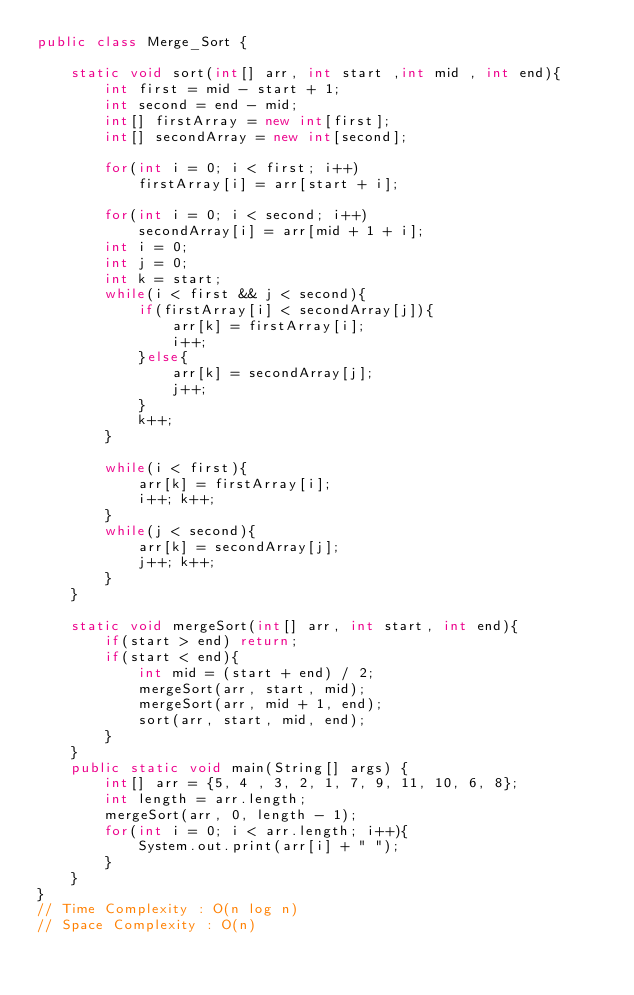<code> <loc_0><loc_0><loc_500><loc_500><_Java_>public class Merge_Sort {

    static void sort(int[] arr, int start ,int mid , int end){
        int first = mid - start + 1;
        int second = end - mid;
        int[] firstArray = new int[first];
        int[] secondArray = new int[second];
        
        for(int i = 0; i < first; i++)
            firstArray[i] = arr[start + i];
        
        for(int i = 0; i < second; i++)
            secondArray[i] = arr[mid + 1 + i];
        int i = 0;
        int j = 0;
        int k = start;
        while(i < first && j < second){
            if(firstArray[i] < secondArray[j]){
                arr[k] = firstArray[i];
                i++;
            }else{
                arr[k] = secondArray[j];
                j++;
            }
            k++;
        }

        while(i < first){
            arr[k] = firstArray[i];
            i++; k++;
        }
        while(j < second){
            arr[k] = secondArray[j];
            j++; k++;
        }
    }
    
    static void mergeSort(int[] arr, int start, int end){
        if(start > end) return;
        if(start < end){
            int mid = (start + end) / 2;
            mergeSort(arr, start, mid);
            mergeSort(arr, mid + 1, end);
            sort(arr, start, mid, end);
        }
    }
    public static void main(String[] args) {
        int[] arr = {5, 4 , 3, 2, 1, 7, 9, 11, 10, 6, 8};
        int length = arr.length;
        mergeSort(arr, 0, length - 1);
        for(int i = 0; i < arr.length; i++){
            System.out.print(arr[i] + " ");
        }
    }
}
// Time Complexity : O(n log n)
// Space Complexity : O(n)
</code> 